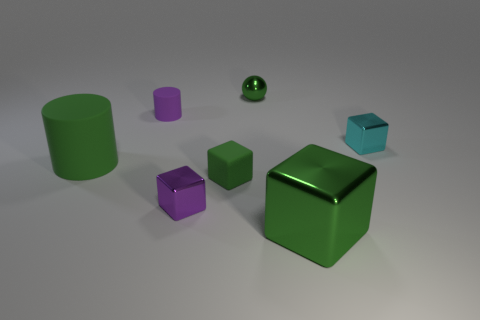Subtract all green blocks. How many were subtracted if there are1green blocks left? 1 Add 3 big yellow rubber blocks. How many objects exist? 10 Subtract all small purple cubes. How many cubes are left? 3 Subtract all green balls. How many green blocks are left? 2 Subtract all cyan blocks. How many blocks are left? 3 Add 7 tiny cyan shiny cubes. How many tiny cyan shiny cubes are left? 8 Add 3 large yellow metal cubes. How many large yellow metal cubes exist? 3 Subtract 0 purple spheres. How many objects are left? 7 Subtract all spheres. How many objects are left? 6 Subtract 1 balls. How many balls are left? 0 